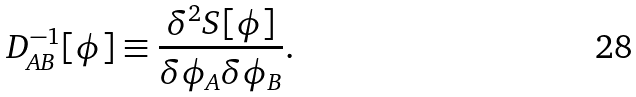Convert formula to latex. <formula><loc_0><loc_0><loc_500><loc_500>D _ { A B } ^ { - 1 } [ \phi ] \equiv \frac { \delta ^ { 2 } S [ \phi ] } { \delta \phi _ { A } \delta \phi _ { B } } .</formula> 